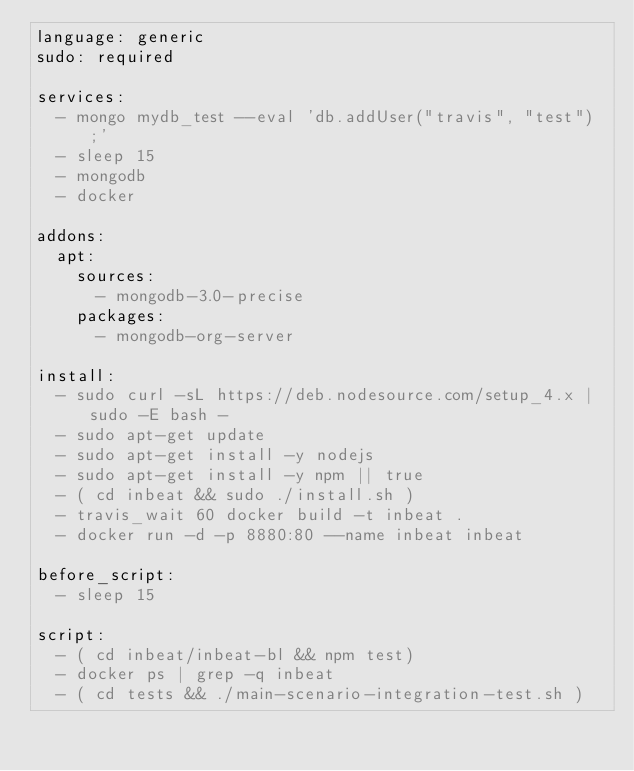<code> <loc_0><loc_0><loc_500><loc_500><_YAML_>language: generic
sudo: required

services:
  - mongo mydb_test --eval 'db.addUser("travis", "test");'
  - sleep 15
  - mongodb
  - docker

addons:
  apt:
    sources:
      - mongodb-3.0-precise
    packages:
      - mongodb-org-server

install:
  - sudo curl -sL https://deb.nodesource.com/setup_4.x | sudo -E bash -
  - sudo apt-get update
  - sudo apt-get install -y nodejs
  - sudo apt-get install -y npm || true
  - ( cd inbeat && sudo ./install.sh )
  - travis_wait 60 docker build -t inbeat .
  - docker run -d -p 8880:80 --name inbeat inbeat

before_script:
  - sleep 15

script:
  - ( cd inbeat/inbeat-bl && npm test)
  - docker ps | grep -q inbeat
  - ( cd tests && ./main-scenario-integration-test.sh )
</code> 